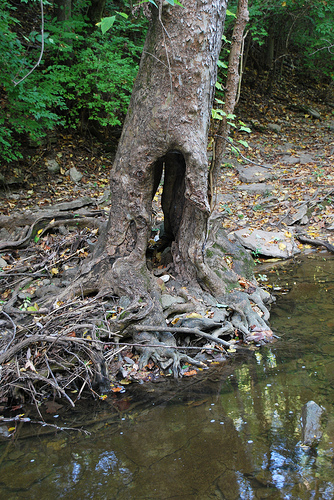<image>
Is the tree next to the water? Yes. The tree is positioned adjacent to the water, located nearby in the same general area. 